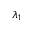<formula> <loc_0><loc_0><loc_500><loc_500>\lambda _ { 1 }</formula> 